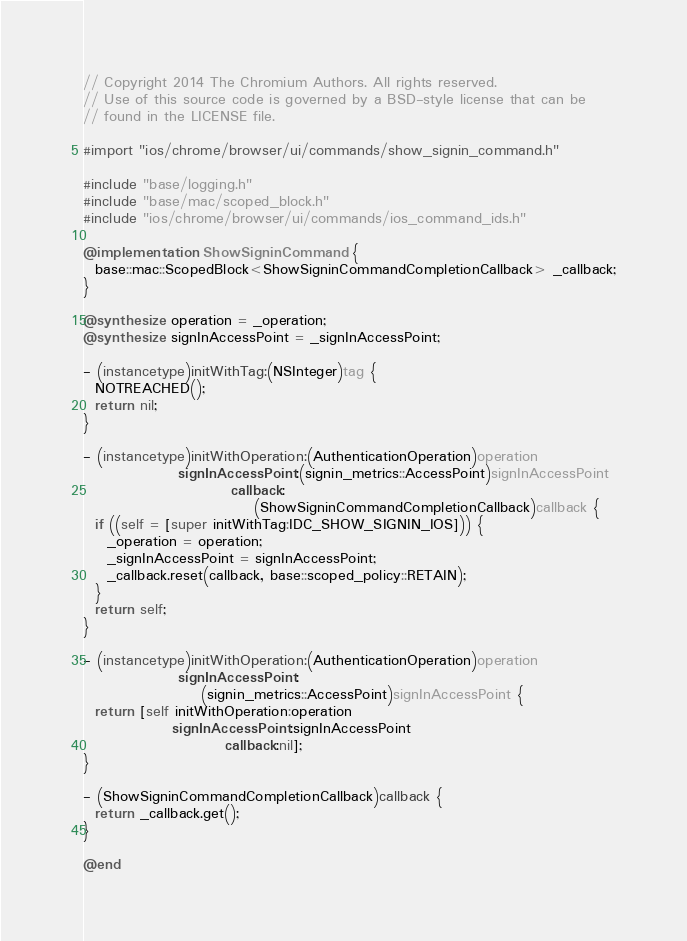Convert code to text. <code><loc_0><loc_0><loc_500><loc_500><_ObjectiveC_>// Copyright 2014 The Chromium Authors. All rights reserved.
// Use of this source code is governed by a BSD-style license that can be
// found in the LICENSE file.

#import "ios/chrome/browser/ui/commands/show_signin_command.h"

#include "base/logging.h"
#include "base/mac/scoped_block.h"
#include "ios/chrome/browser/ui/commands/ios_command_ids.h"

@implementation ShowSigninCommand {
  base::mac::ScopedBlock<ShowSigninCommandCompletionCallback> _callback;
}

@synthesize operation = _operation;
@synthesize signInAccessPoint = _signInAccessPoint;

- (instancetype)initWithTag:(NSInteger)tag {
  NOTREACHED();
  return nil;
}

- (instancetype)initWithOperation:(AuthenticationOperation)operation
                signInAccessPoint:(signin_metrics::AccessPoint)signInAccessPoint
                         callback:
                             (ShowSigninCommandCompletionCallback)callback {
  if ((self = [super initWithTag:IDC_SHOW_SIGNIN_IOS])) {
    _operation = operation;
    _signInAccessPoint = signInAccessPoint;
    _callback.reset(callback, base::scoped_policy::RETAIN);
  }
  return self;
}

- (instancetype)initWithOperation:(AuthenticationOperation)operation
                signInAccessPoint:
                    (signin_metrics::AccessPoint)signInAccessPoint {
  return [self initWithOperation:operation
               signInAccessPoint:signInAccessPoint
                        callback:nil];
}

- (ShowSigninCommandCompletionCallback)callback {
  return _callback.get();
}

@end
</code> 